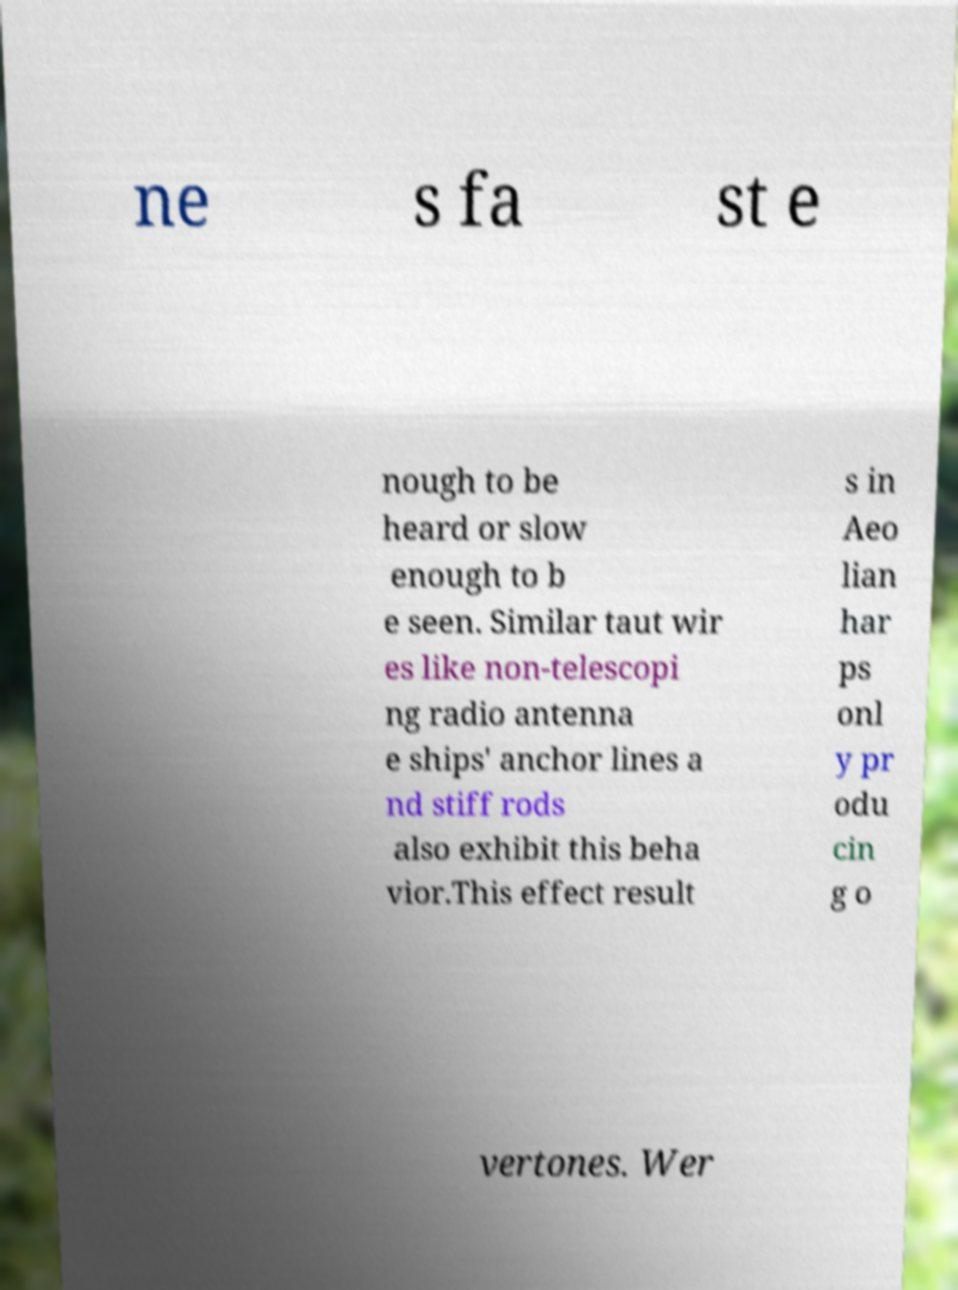Could you assist in decoding the text presented in this image and type it out clearly? ne s fa st e nough to be heard or slow enough to b e seen. Similar taut wir es like non-telescopi ng radio antenna e ships' anchor lines a nd stiff rods also exhibit this beha vior.This effect result s in Aeo lian har ps onl y pr odu cin g o vertones. Wer 